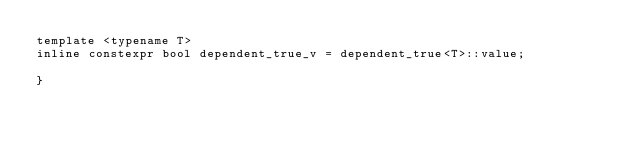<code> <loc_0><loc_0><loc_500><loc_500><_C_>template <typename T>
inline constexpr bool dependent_true_v = dependent_true<T>::value;

}
</code> 